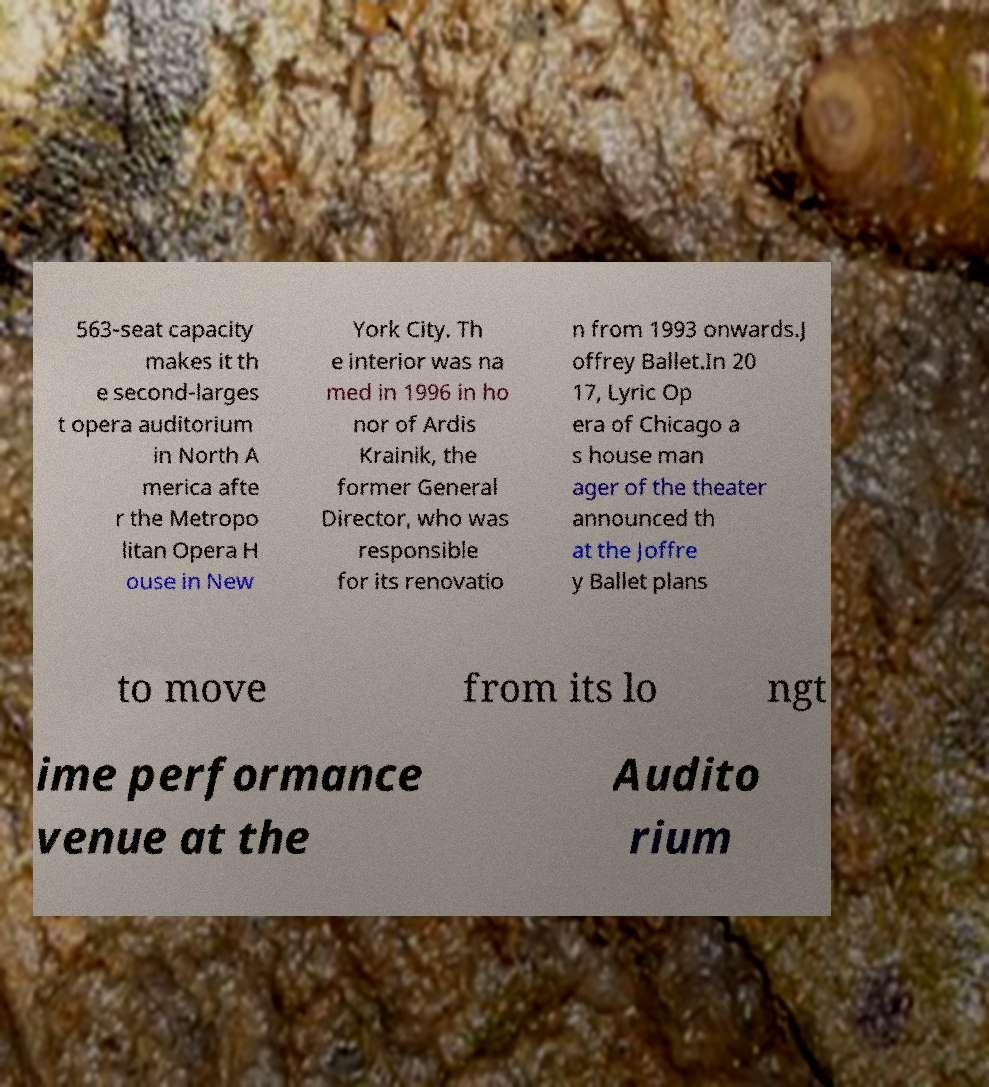Please read and relay the text visible in this image. What does it say? 563-seat capacity makes it th e second-larges t opera auditorium in North A merica afte r the Metropo litan Opera H ouse in New York City. Th e interior was na med in 1996 in ho nor of Ardis Krainik, the former General Director, who was responsible for its renovatio n from 1993 onwards.J offrey Ballet.In 20 17, Lyric Op era of Chicago a s house man ager of the theater announced th at the Joffre y Ballet plans to move from its lo ngt ime performance venue at the Audito rium 